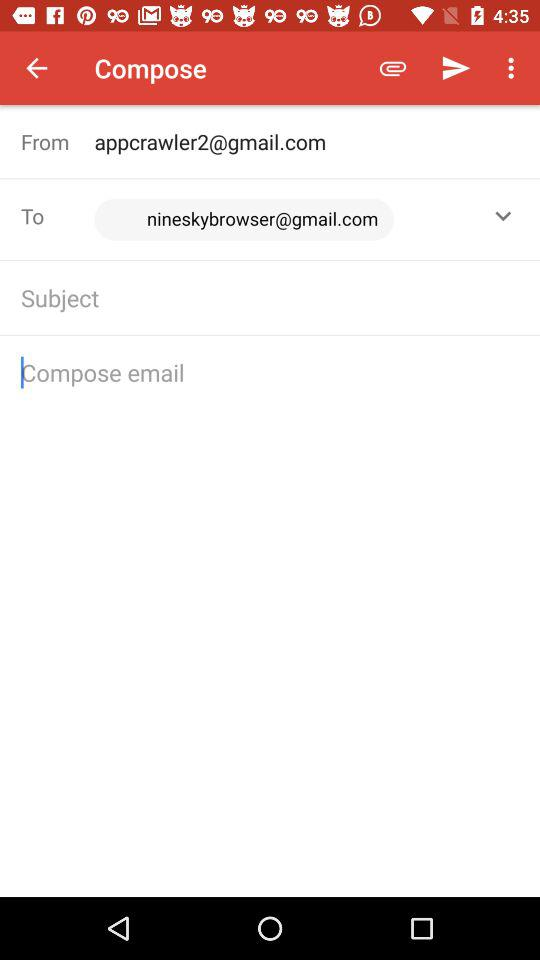What is the email address given in "To"? The email address is nineskybrowser@gmail.com. 